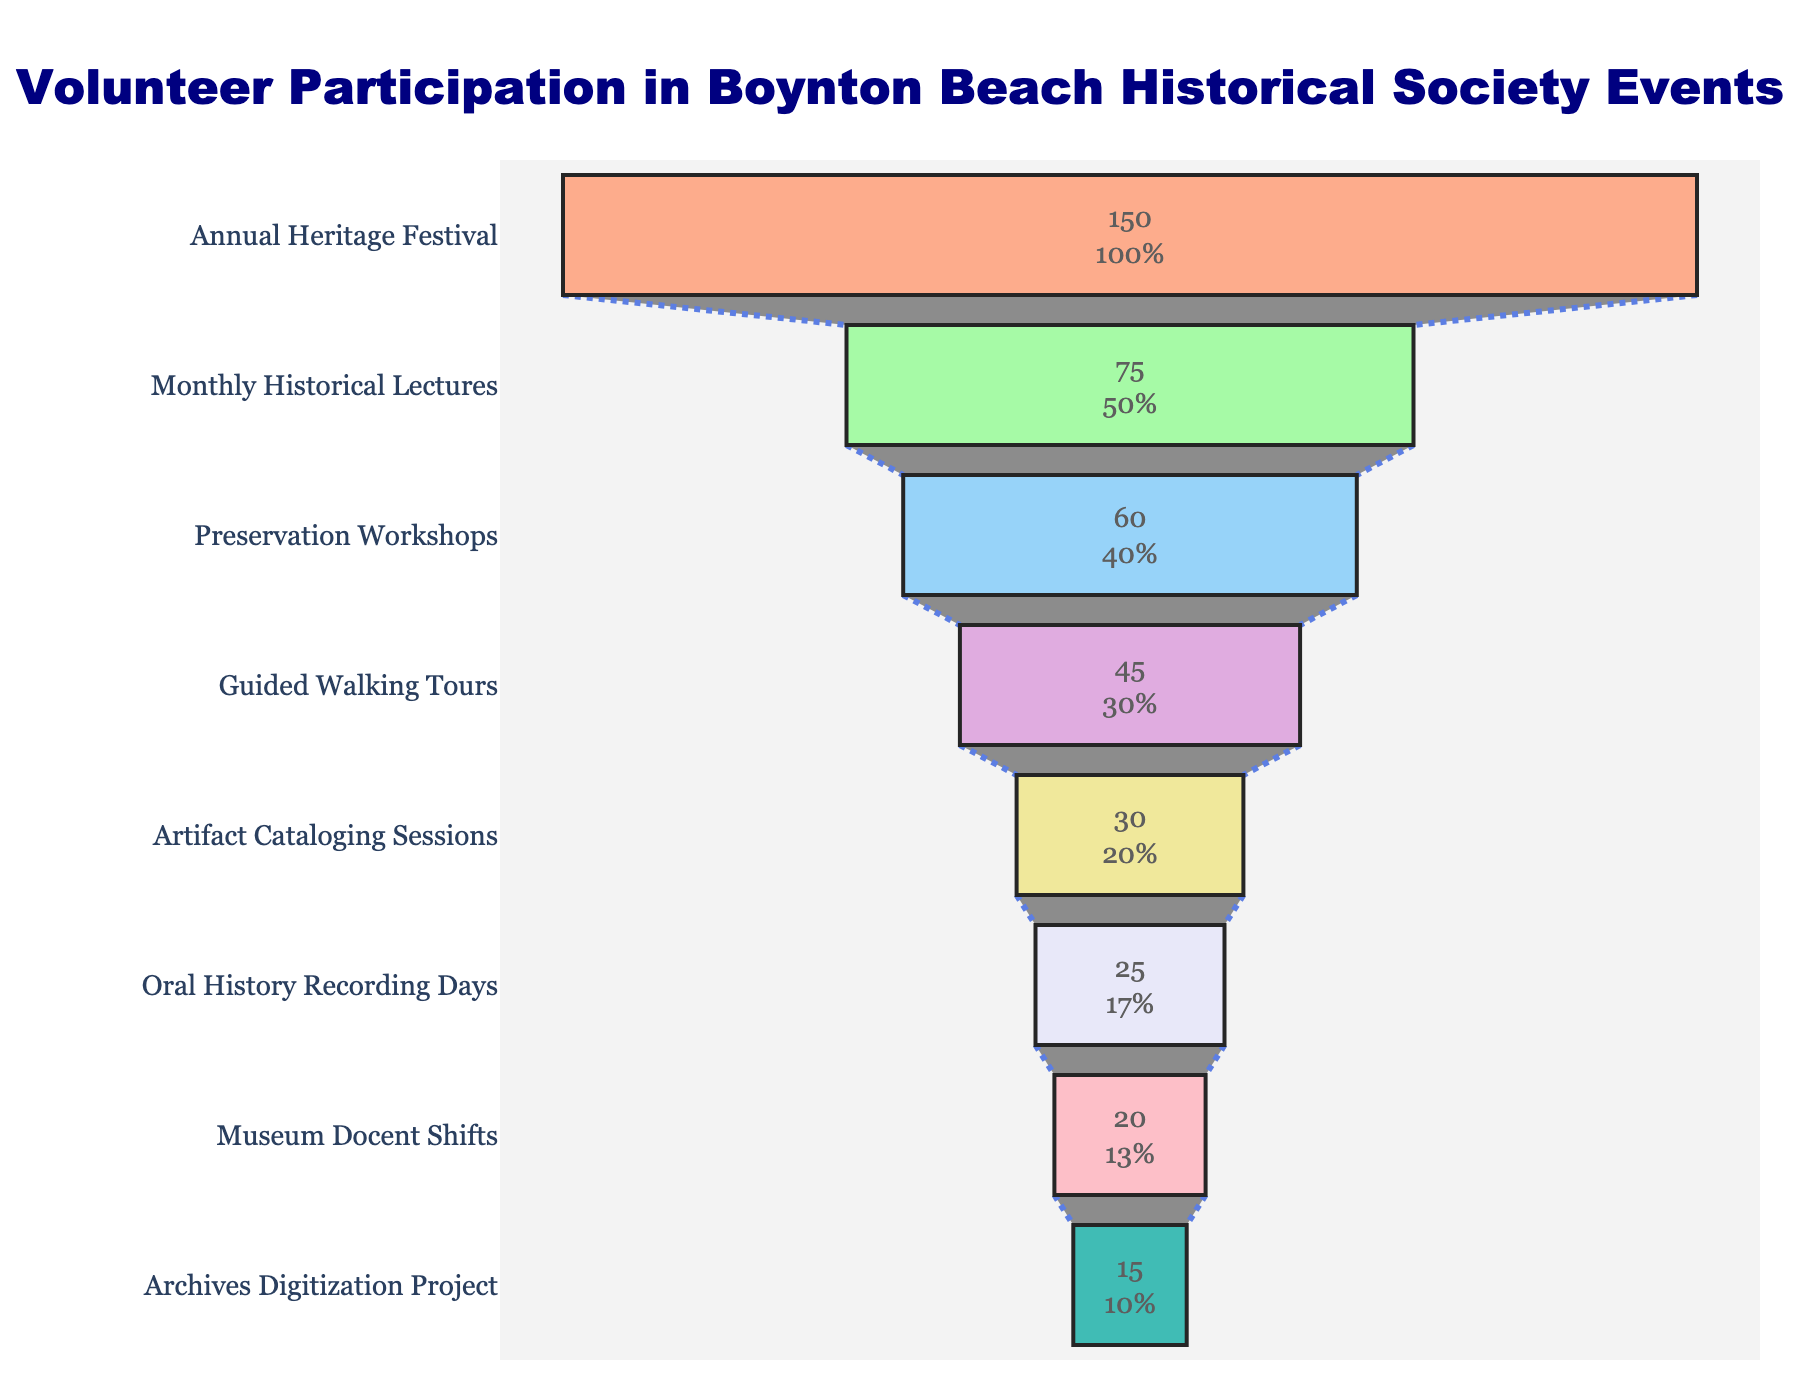What's the title of the figure? The title is displayed at the top of the figure, centered and highlighted in large font for easy identification.
Answer: Volunteer Participation in Boynton Beach Historical Society Events How many events are shown in the funnel chart? Count each event listed along the vertical axis from top to bottom.
Answer: 8 Which event has the highest volunteer participation? Identify the event located at the widest part of the funnel, which represents the highest participation level.
Answer: Annual Heritage Festival By how much does participation in Preservation Workshops exceed that in Guided Walking Tours? Locate both events in the funnel chart, then subtract the number of volunteers for Guided Walking Tours from that of Preservation Workshops.
Answer: 15 What's the total number of volunteers participating in all events? Add the number of volunteers for each event listed on the chart: 150 + 75 + 60 + 45 + 30 + 25 + 20 + 15.
Answer: 420 What percentage of volunteers participate in the Monthly Historical Lectures compared to the Annual Heritage Festival? Divide the number of volunteers in Monthly Historical Lectures (75) by those in the Annual Heritage Festival (150), then multiply by 100 to convert to a percentage.
Answer: 50% Which event has the lowest volunteer participation, and what is that number? Identify the event at the narrowest part of the funnel, representing the lowest participation level, and note its associated number of volunteers.
Answer: Archives Digitization Project, 15 How does the participation in Museum Docent Shifts compare to Oral History Recording Days? Locate both events in the funnel chart and note that Museum Docent Shifts have 20 volunteers while Oral History Recording Days have 25.
Answer: Oral History Recording Days have 5 more volunteers What is the combined participation of the events with fewer than 50 volunteers? Identify events with fewer than 50 volunteers, then sum their numbers: 45 + 30 + 25 + 20 + 15.
Answer: 135 Is there a significant drop in volunteer participation between any two consecutive events? Examine the funnel chart for the steepest decrease between consecutive events, comparing gaps between the descending levels.
Answer: Significant drop between Annual Heritage Festival and Monthly Historical Lectures 